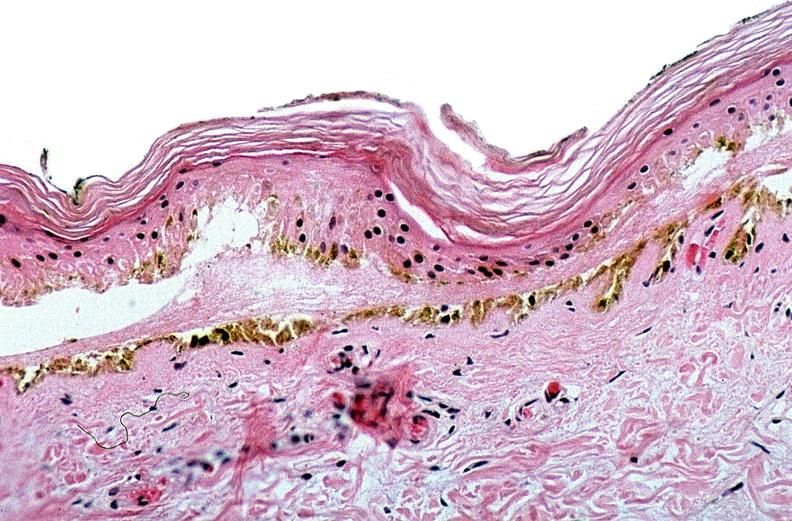does this image show thermal burned skin?
Answer the question using a single word or phrase. Yes 